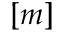Convert formula to latex. <formula><loc_0><loc_0><loc_500><loc_500>[ m ]</formula> 